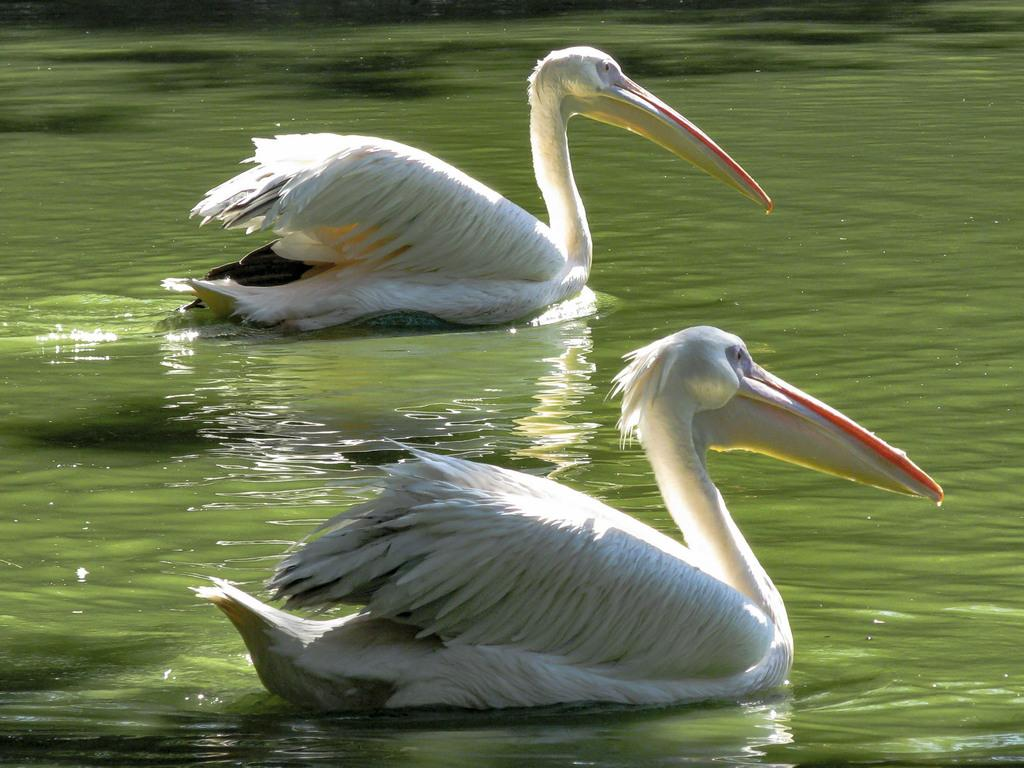What animals are present in the image? There are two swans in the image. Where are the swans located? The swans are on the water. What type of teeth can be seen in the image? There are no teeth visible in the image, as it features swans on the water. How many goldfish are swimming with the swans in the image? There are no goldfish present in the image; it only features two swans on the water. 